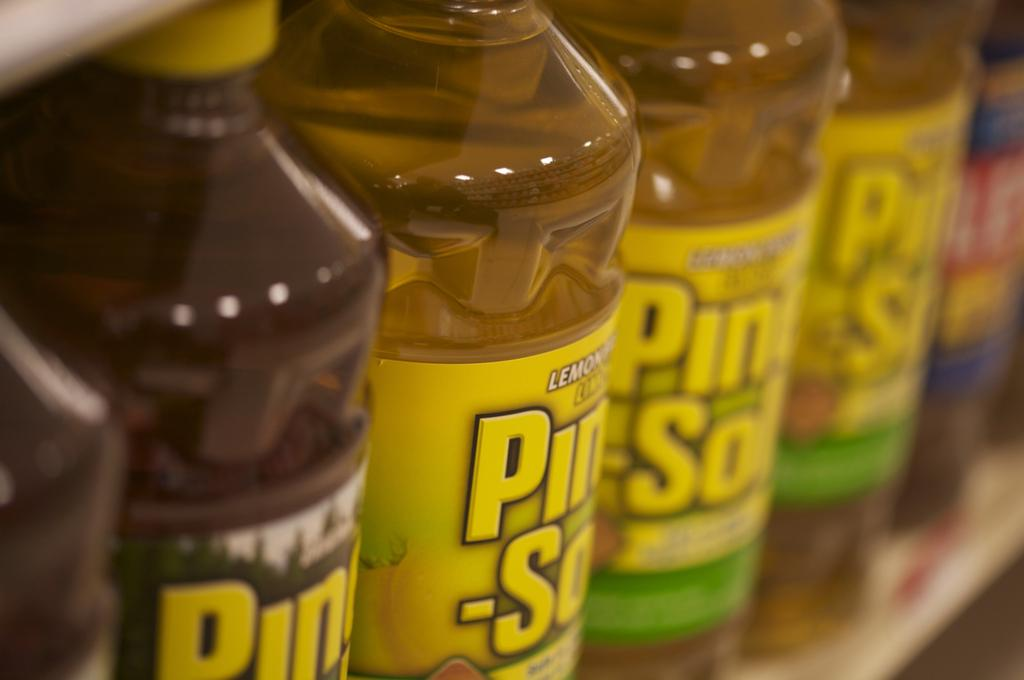<image>
Create a compact narrative representing the image presented. Many bottles of Pine-Sol sit on a shelf 